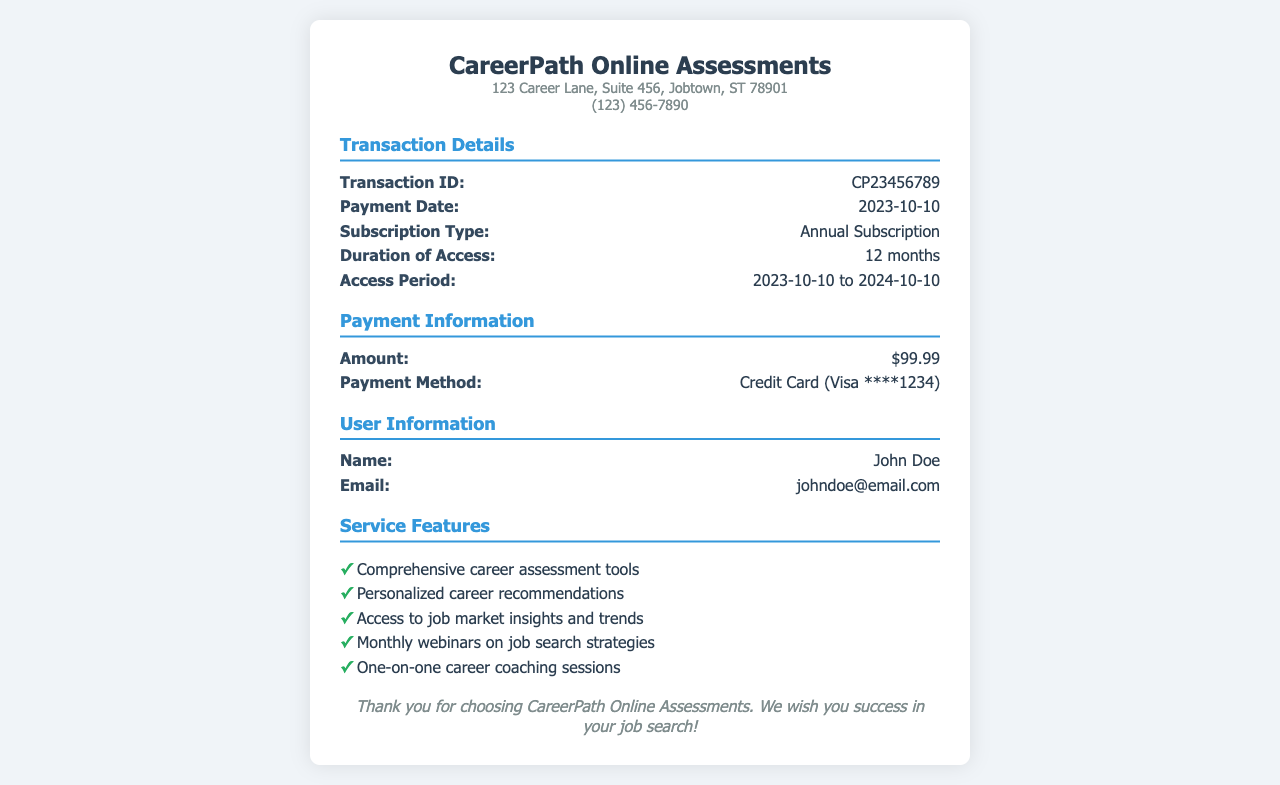What is the transaction ID? The transaction ID can be found in the "Transaction Details" section of the receipt.
Answer: CP23456789 When was the payment made? The payment date is listed in the "Transaction Details" section under "Payment Date."
Answer: 2023-10-10 How long is the duration of access? The duration of access is stated in the "Transaction Details" section under "Duration of Access."
Answer: 12 months What is the access period? The access period is mentioned in the "Transaction Details" section under "Access Period."
Answer: 2023-10-10 to 2024-10-10 What is the total amount paid? The total amount paid can be found in the "Payment Information" section under "Amount."
Answer: $99.99 What payment method was used? The payment method is detailed in the "Payment Information" section under "Payment Method."
Answer: Credit Card (Visa ****1234) What services are included in this subscription? The services are listed in the "Service Features" section.
Answer: Comprehensive career assessment tools, personalized career recommendations, access to job market insights and trends, monthly webinars on job search strategies, one-on-one career coaching sessions Who is the user of this subscription? The user information is provided in the "User Information" section.
Answer: John Doe What is the company name? The company name is at the top of the receipt in the header.
Answer: CareerPath Online Assessments 